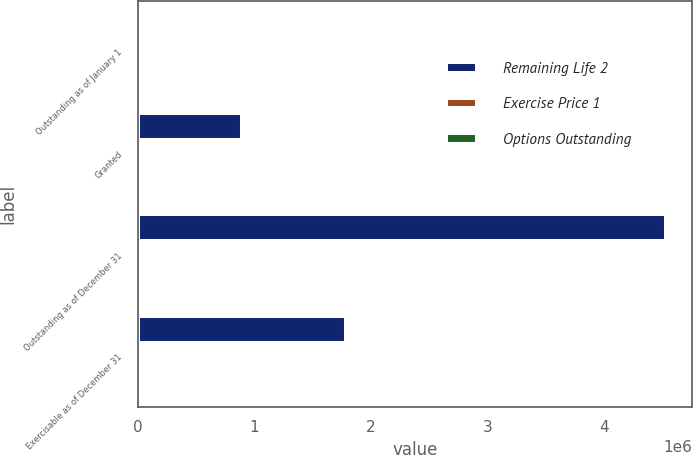<chart> <loc_0><loc_0><loc_500><loc_500><stacked_bar_chart><ecel><fcel>Outstanding as of January 1<fcel>Granted<fcel>Outstanding as of December 31<fcel>Exercisable as of December 31<nl><fcel>Remaining Life 2<fcel>38.52<fcel>893220<fcel>4.53098e+06<fcel>1.79224e+06<nl><fcel>Exercise Price 1<fcel>38.52<fcel>42<fcel>41.49<fcel>31<nl><fcel>Options Outstanding<fcel>4.59<fcel>8.41<fcel>4.89<fcel>2.15<nl></chart> 